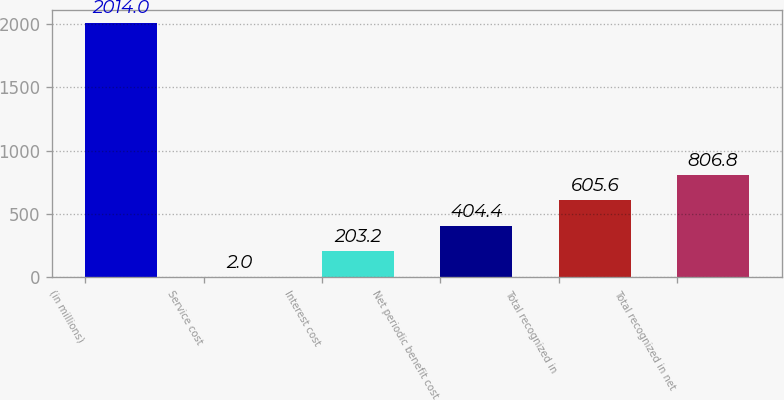<chart> <loc_0><loc_0><loc_500><loc_500><bar_chart><fcel>(in millions)<fcel>Service cost<fcel>Interest cost<fcel>Net periodic benefit cost<fcel>Total recognized in<fcel>Total recognized in net<nl><fcel>2014<fcel>2<fcel>203.2<fcel>404.4<fcel>605.6<fcel>806.8<nl></chart> 